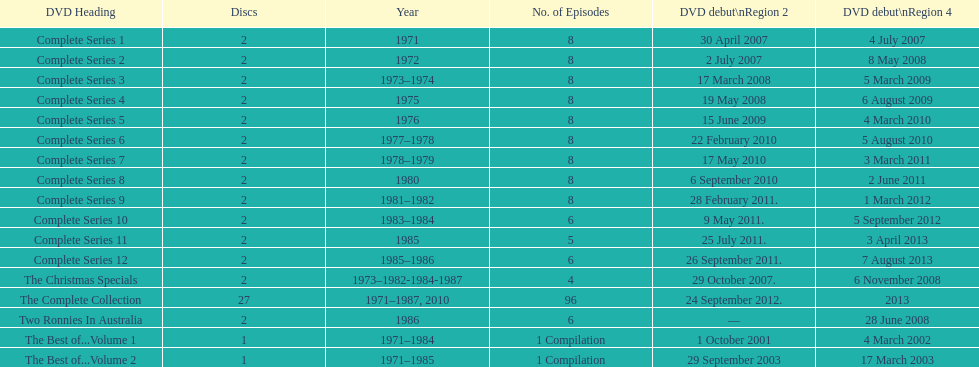How many "best of" volumes compile the top episodes of the television show "the two ronnies". 2. 